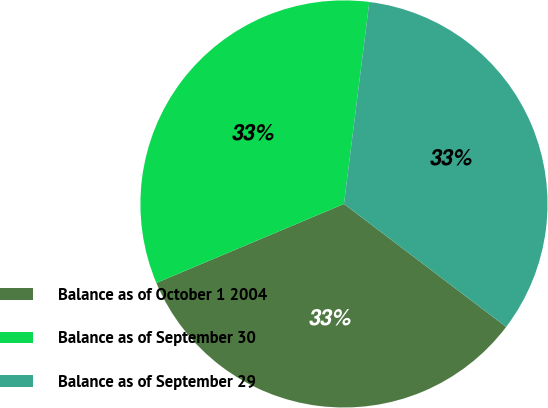<chart> <loc_0><loc_0><loc_500><loc_500><pie_chart><fcel>Balance as of October 1 2004<fcel>Balance as of September 30<fcel>Balance as of September 29<nl><fcel>33.33%<fcel>33.33%<fcel>33.33%<nl></chart> 